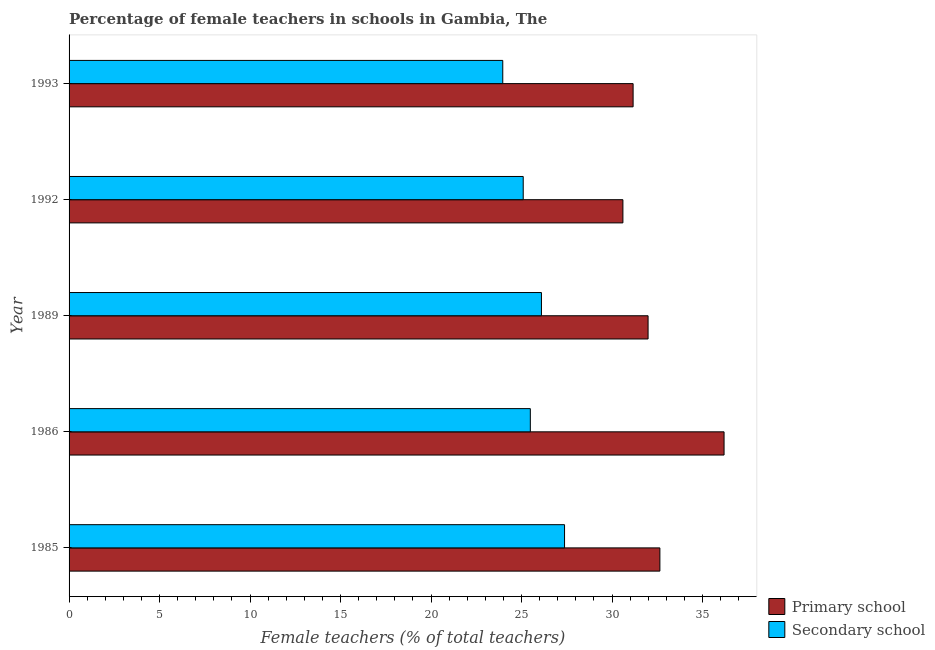How many different coloured bars are there?
Keep it short and to the point. 2. How many groups of bars are there?
Provide a short and direct response. 5. Are the number of bars on each tick of the Y-axis equal?
Ensure brevity in your answer.  Yes. In how many cases, is the number of bars for a given year not equal to the number of legend labels?
Your answer should be very brief. 0. What is the percentage of female teachers in secondary schools in 1992?
Provide a succinct answer. 25.09. Across all years, what is the maximum percentage of female teachers in secondary schools?
Give a very brief answer. 27.37. Across all years, what is the minimum percentage of female teachers in primary schools?
Ensure brevity in your answer.  30.6. What is the total percentage of female teachers in secondary schools in the graph?
Make the answer very short. 128.01. What is the difference between the percentage of female teachers in primary schools in 1985 and that in 1989?
Ensure brevity in your answer.  0.65. What is the difference between the percentage of female teachers in primary schools in 1985 and the percentage of female teachers in secondary schools in 1986?
Provide a succinct answer. 7.16. What is the average percentage of female teachers in secondary schools per year?
Offer a very short reply. 25.6. In the year 1989, what is the difference between the percentage of female teachers in primary schools and percentage of female teachers in secondary schools?
Give a very brief answer. 5.89. In how many years, is the percentage of female teachers in primary schools greater than 7 %?
Keep it short and to the point. 5. What is the ratio of the percentage of female teachers in secondary schools in 1986 to that in 1989?
Your answer should be very brief. 0.98. Is the difference between the percentage of female teachers in primary schools in 1992 and 1993 greater than the difference between the percentage of female teachers in secondary schools in 1992 and 1993?
Offer a terse response. No. What is the difference between the highest and the second highest percentage of female teachers in primary schools?
Provide a succinct answer. 3.54. What is the difference between the highest and the lowest percentage of female teachers in secondary schools?
Offer a very short reply. 3.41. What does the 1st bar from the top in 1993 represents?
Your answer should be compact. Secondary school. What does the 1st bar from the bottom in 1992 represents?
Provide a short and direct response. Primary school. How many bars are there?
Give a very brief answer. 10. Are all the bars in the graph horizontal?
Ensure brevity in your answer.  Yes. What is the difference between two consecutive major ticks on the X-axis?
Offer a very short reply. 5. Are the values on the major ticks of X-axis written in scientific E-notation?
Provide a succinct answer. No. Does the graph contain grids?
Your answer should be very brief. No. Where does the legend appear in the graph?
Ensure brevity in your answer.  Bottom right. How many legend labels are there?
Ensure brevity in your answer.  2. How are the legend labels stacked?
Make the answer very short. Vertical. What is the title of the graph?
Your answer should be compact. Percentage of female teachers in schools in Gambia, The. What is the label or title of the X-axis?
Offer a very short reply. Female teachers (% of total teachers). What is the label or title of the Y-axis?
Make the answer very short. Year. What is the Female teachers (% of total teachers) in Primary school in 1985?
Offer a very short reply. 32.64. What is the Female teachers (% of total teachers) in Secondary school in 1985?
Keep it short and to the point. 27.37. What is the Female teachers (% of total teachers) of Primary school in 1986?
Offer a very short reply. 36.19. What is the Female teachers (% of total teachers) in Secondary school in 1986?
Your answer should be very brief. 25.48. What is the Female teachers (% of total teachers) of Primary school in 1989?
Your answer should be very brief. 31.99. What is the Female teachers (% of total teachers) in Secondary school in 1989?
Keep it short and to the point. 26.1. What is the Female teachers (% of total teachers) in Primary school in 1992?
Give a very brief answer. 30.6. What is the Female teachers (% of total teachers) of Secondary school in 1992?
Provide a succinct answer. 25.09. What is the Female teachers (% of total teachers) in Primary school in 1993?
Your response must be concise. 31.16. What is the Female teachers (% of total teachers) of Secondary school in 1993?
Offer a very short reply. 23.96. Across all years, what is the maximum Female teachers (% of total teachers) of Primary school?
Offer a very short reply. 36.19. Across all years, what is the maximum Female teachers (% of total teachers) in Secondary school?
Provide a succinct answer. 27.37. Across all years, what is the minimum Female teachers (% of total teachers) in Primary school?
Offer a terse response. 30.6. Across all years, what is the minimum Female teachers (% of total teachers) of Secondary school?
Your answer should be compact. 23.96. What is the total Female teachers (% of total teachers) in Primary school in the graph?
Your response must be concise. 162.58. What is the total Female teachers (% of total teachers) in Secondary school in the graph?
Offer a terse response. 128.01. What is the difference between the Female teachers (% of total teachers) of Primary school in 1985 and that in 1986?
Offer a terse response. -3.54. What is the difference between the Female teachers (% of total teachers) of Secondary school in 1985 and that in 1986?
Offer a very short reply. 1.89. What is the difference between the Female teachers (% of total teachers) in Primary school in 1985 and that in 1989?
Make the answer very short. 0.65. What is the difference between the Female teachers (% of total teachers) of Secondary school in 1985 and that in 1989?
Ensure brevity in your answer.  1.28. What is the difference between the Female teachers (% of total teachers) of Primary school in 1985 and that in 1992?
Your answer should be compact. 2.04. What is the difference between the Female teachers (% of total teachers) in Secondary school in 1985 and that in 1992?
Your answer should be compact. 2.28. What is the difference between the Female teachers (% of total teachers) in Primary school in 1985 and that in 1993?
Provide a succinct answer. 1.48. What is the difference between the Female teachers (% of total teachers) of Secondary school in 1985 and that in 1993?
Your answer should be compact. 3.41. What is the difference between the Female teachers (% of total teachers) in Primary school in 1986 and that in 1989?
Ensure brevity in your answer.  4.2. What is the difference between the Female teachers (% of total teachers) of Secondary school in 1986 and that in 1989?
Ensure brevity in your answer.  -0.61. What is the difference between the Female teachers (% of total teachers) in Primary school in 1986 and that in 1992?
Offer a very short reply. 5.59. What is the difference between the Female teachers (% of total teachers) in Secondary school in 1986 and that in 1992?
Provide a succinct answer. 0.39. What is the difference between the Female teachers (% of total teachers) of Primary school in 1986 and that in 1993?
Ensure brevity in your answer.  5.02. What is the difference between the Female teachers (% of total teachers) in Secondary school in 1986 and that in 1993?
Provide a succinct answer. 1.52. What is the difference between the Female teachers (% of total teachers) of Primary school in 1989 and that in 1992?
Keep it short and to the point. 1.39. What is the difference between the Female teachers (% of total teachers) in Secondary school in 1989 and that in 1992?
Keep it short and to the point. 1.01. What is the difference between the Female teachers (% of total teachers) of Primary school in 1989 and that in 1993?
Your response must be concise. 0.83. What is the difference between the Female teachers (% of total teachers) of Secondary school in 1989 and that in 1993?
Make the answer very short. 2.14. What is the difference between the Female teachers (% of total teachers) in Primary school in 1992 and that in 1993?
Keep it short and to the point. -0.56. What is the difference between the Female teachers (% of total teachers) in Secondary school in 1992 and that in 1993?
Provide a short and direct response. 1.13. What is the difference between the Female teachers (% of total teachers) in Primary school in 1985 and the Female teachers (% of total teachers) in Secondary school in 1986?
Keep it short and to the point. 7.16. What is the difference between the Female teachers (% of total teachers) in Primary school in 1985 and the Female teachers (% of total teachers) in Secondary school in 1989?
Ensure brevity in your answer.  6.54. What is the difference between the Female teachers (% of total teachers) of Primary school in 1985 and the Female teachers (% of total teachers) of Secondary school in 1992?
Make the answer very short. 7.55. What is the difference between the Female teachers (% of total teachers) of Primary school in 1985 and the Female teachers (% of total teachers) of Secondary school in 1993?
Ensure brevity in your answer.  8.68. What is the difference between the Female teachers (% of total teachers) in Primary school in 1986 and the Female teachers (% of total teachers) in Secondary school in 1989?
Give a very brief answer. 10.09. What is the difference between the Female teachers (% of total teachers) of Primary school in 1986 and the Female teachers (% of total teachers) of Secondary school in 1992?
Your response must be concise. 11.1. What is the difference between the Female teachers (% of total teachers) in Primary school in 1986 and the Female teachers (% of total teachers) in Secondary school in 1993?
Provide a short and direct response. 12.23. What is the difference between the Female teachers (% of total teachers) in Primary school in 1989 and the Female teachers (% of total teachers) in Secondary school in 1992?
Offer a very short reply. 6.9. What is the difference between the Female teachers (% of total teachers) of Primary school in 1989 and the Female teachers (% of total teachers) of Secondary school in 1993?
Offer a very short reply. 8.03. What is the difference between the Female teachers (% of total teachers) in Primary school in 1992 and the Female teachers (% of total teachers) in Secondary school in 1993?
Offer a terse response. 6.64. What is the average Female teachers (% of total teachers) in Primary school per year?
Give a very brief answer. 32.52. What is the average Female teachers (% of total teachers) in Secondary school per year?
Keep it short and to the point. 25.6. In the year 1985, what is the difference between the Female teachers (% of total teachers) in Primary school and Female teachers (% of total teachers) in Secondary school?
Offer a very short reply. 5.27. In the year 1986, what is the difference between the Female teachers (% of total teachers) of Primary school and Female teachers (% of total teachers) of Secondary school?
Provide a short and direct response. 10.7. In the year 1989, what is the difference between the Female teachers (% of total teachers) of Primary school and Female teachers (% of total teachers) of Secondary school?
Your response must be concise. 5.89. In the year 1992, what is the difference between the Female teachers (% of total teachers) in Primary school and Female teachers (% of total teachers) in Secondary school?
Provide a short and direct response. 5.51. In the year 1993, what is the difference between the Female teachers (% of total teachers) of Primary school and Female teachers (% of total teachers) of Secondary school?
Make the answer very short. 7.2. What is the ratio of the Female teachers (% of total teachers) of Primary school in 1985 to that in 1986?
Offer a terse response. 0.9. What is the ratio of the Female teachers (% of total teachers) in Secondary school in 1985 to that in 1986?
Make the answer very short. 1.07. What is the ratio of the Female teachers (% of total teachers) of Primary school in 1985 to that in 1989?
Your answer should be very brief. 1.02. What is the ratio of the Female teachers (% of total teachers) in Secondary school in 1985 to that in 1989?
Give a very brief answer. 1.05. What is the ratio of the Female teachers (% of total teachers) of Primary school in 1985 to that in 1992?
Ensure brevity in your answer.  1.07. What is the ratio of the Female teachers (% of total teachers) in Secondary school in 1985 to that in 1992?
Offer a terse response. 1.09. What is the ratio of the Female teachers (% of total teachers) in Primary school in 1985 to that in 1993?
Provide a short and direct response. 1.05. What is the ratio of the Female teachers (% of total teachers) of Secondary school in 1985 to that in 1993?
Give a very brief answer. 1.14. What is the ratio of the Female teachers (% of total teachers) in Primary school in 1986 to that in 1989?
Make the answer very short. 1.13. What is the ratio of the Female teachers (% of total teachers) of Secondary school in 1986 to that in 1989?
Provide a short and direct response. 0.98. What is the ratio of the Female teachers (% of total teachers) of Primary school in 1986 to that in 1992?
Offer a terse response. 1.18. What is the ratio of the Female teachers (% of total teachers) in Secondary school in 1986 to that in 1992?
Keep it short and to the point. 1.02. What is the ratio of the Female teachers (% of total teachers) of Primary school in 1986 to that in 1993?
Your response must be concise. 1.16. What is the ratio of the Female teachers (% of total teachers) in Secondary school in 1986 to that in 1993?
Give a very brief answer. 1.06. What is the ratio of the Female teachers (% of total teachers) in Primary school in 1989 to that in 1992?
Give a very brief answer. 1.05. What is the ratio of the Female teachers (% of total teachers) in Secondary school in 1989 to that in 1992?
Offer a very short reply. 1.04. What is the ratio of the Female teachers (% of total teachers) of Primary school in 1989 to that in 1993?
Provide a short and direct response. 1.03. What is the ratio of the Female teachers (% of total teachers) of Secondary school in 1989 to that in 1993?
Offer a very short reply. 1.09. What is the ratio of the Female teachers (% of total teachers) of Primary school in 1992 to that in 1993?
Make the answer very short. 0.98. What is the ratio of the Female teachers (% of total teachers) in Secondary school in 1992 to that in 1993?
Provide a short and direct response. 1.05. What is the difference between the highest and the second highest Female teachers (% of total teachers) in Primary school?
Provide a short and direct response. 3.54. What is the difference between the highest and the second highest Female teachers (% of total teachers) in Secondary school?
Provide a succinct answer. 1.28. What is the difference between the highest and the lowest Female teachers (% of total teachers) of Primary school?
Offer a terse response. 5.59. What is the difference between the highest and the lowest Female teachers (% of total teachers) in Secondary school?
Your answer should be compact. 3.41. 